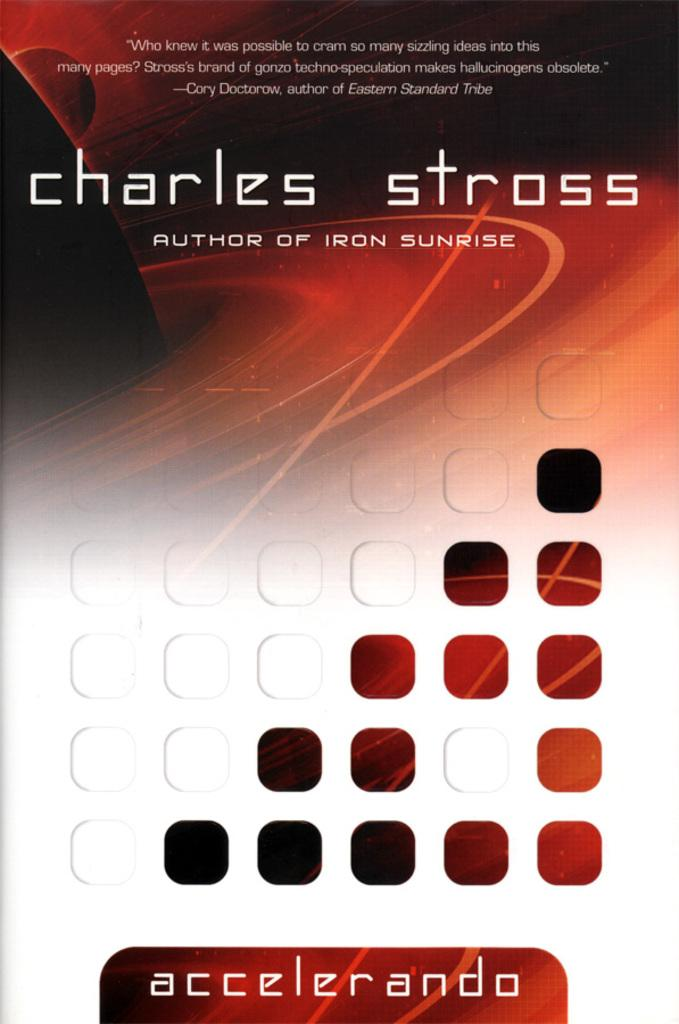Provide a one-sentence caption for the provided image. a book cover that says 'charles stross author of iron sunrise'. 